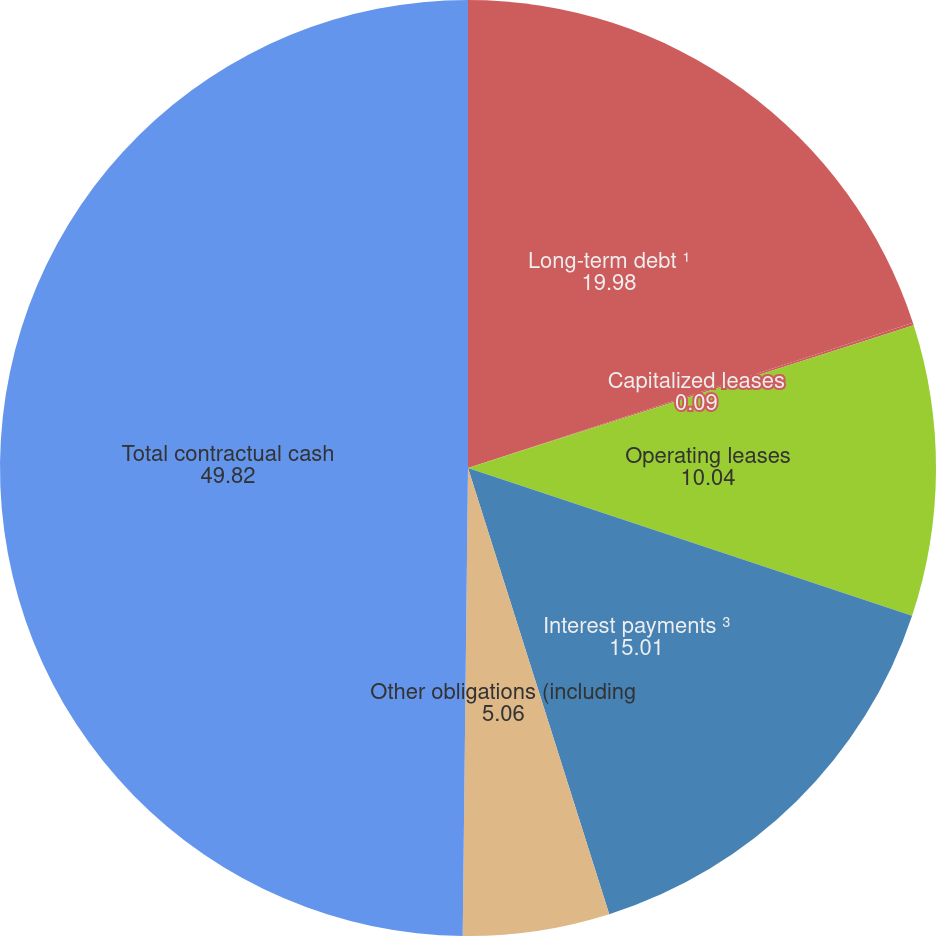<chart> <loc_0><loc_0><loc_500><loc_500><pie_chart><fcel>Long-term debt ¹<fcel>Capitalized leases<fcel>Operating leases<fcel>Interest payments ³<fcel>Other obligations (including<fcel>Total contractual cash<nl><fcel>19.98%<fcel>0.09%<fcel>10.04%<fcel>15.01%<fcel>5.06%<fcel>49.82%<nl></chart> 